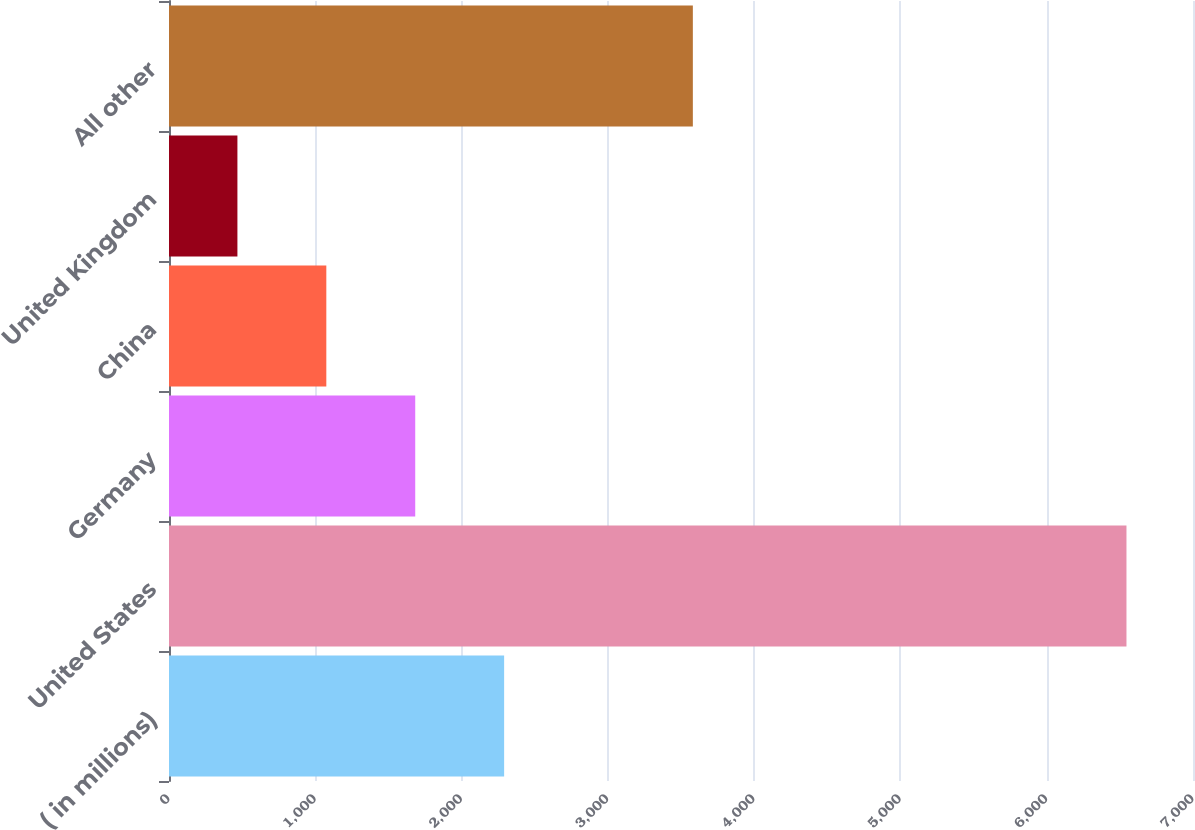Convert chart. <chart><loc_0><loc_0><loc_500><loc_500><bar_chart><fcel>( in millions)<fcel>United States<fcel>Germany<fcel>China<fcel>United Kingdom<fcel>All other<nl><fcel>2290.95<fcel>6545.2<fcel>1683.2<fcel>1075.45<fcel>467.7<fcel>3581<nl></chart> 